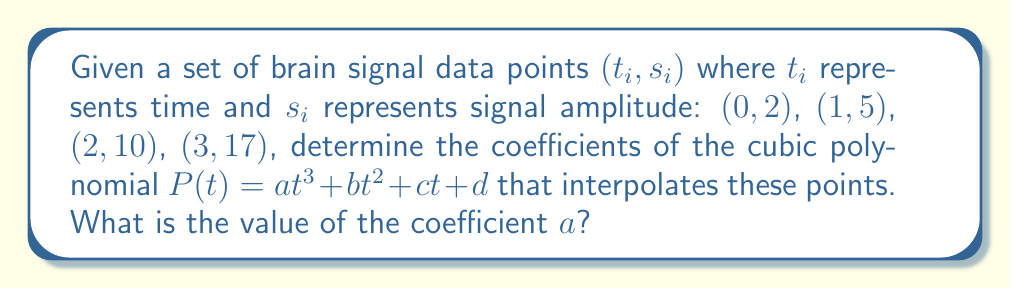Show me your answer to this math problem. To solve this problem, we'll use the Lagrange interpolation method:

1) The Lagrange interpolation polynomial is given by:
   $$P(t) = \sum_{i=0}^{n} s_i L_i(t)$$
   where $L_i(t)$ are the Lagrange basis polynomials.

2) For each point $(t_i, s_i)$, we calculate $L_i(t)$:
   $$L_i(t) = \prod_{j \neq i} \frac{t - t_j}{t_i - t_j}$$

3) Calculating each $L_i(t)$:
   $$L_0(t) = \frac{(t-1)(t-2)(t-3)}{(0-1)(0-2)(0-3)} = -\frac{1}{6}(t-1)(t-2)(t-3)$$
   $$L_1(t) = \frac{(t-0)(t-2)(t-3)}{(1-0)(1-2)(1-3)} = \frac{1}{2}t(t-2)(t-3)$$
   $$L_2(t) = \frac{(t-0)(t-1)(t-3)}{(2-0)(2-1)(2-3)} = -\frac{1}{2}t(t-1)(t-3)$$
   $$L_3(t) = \frac{(t-0)(t-1)(t-2)}{(3-0)(3-1)(3-2)} = \frac{1}{6}t(t-1)(t-2)$$

4) Now, we form the interpolation polynomial:
   $$P(t) = 2L_0(t) + 5L_1(t) + 10L_2(t) + 17L_3(t)$$

5) Expanding and collecting terms:
   $$P(t) = (\frac{1}{3})t^3 + (-\frac{1}{2})t^2 + (\frac{13}{6})t + 2$$

6) Therefore, the coefficient $a$ of $t^3$ is $\frac{1}{3}$.
Answer: $\frac{1}{3}$ 